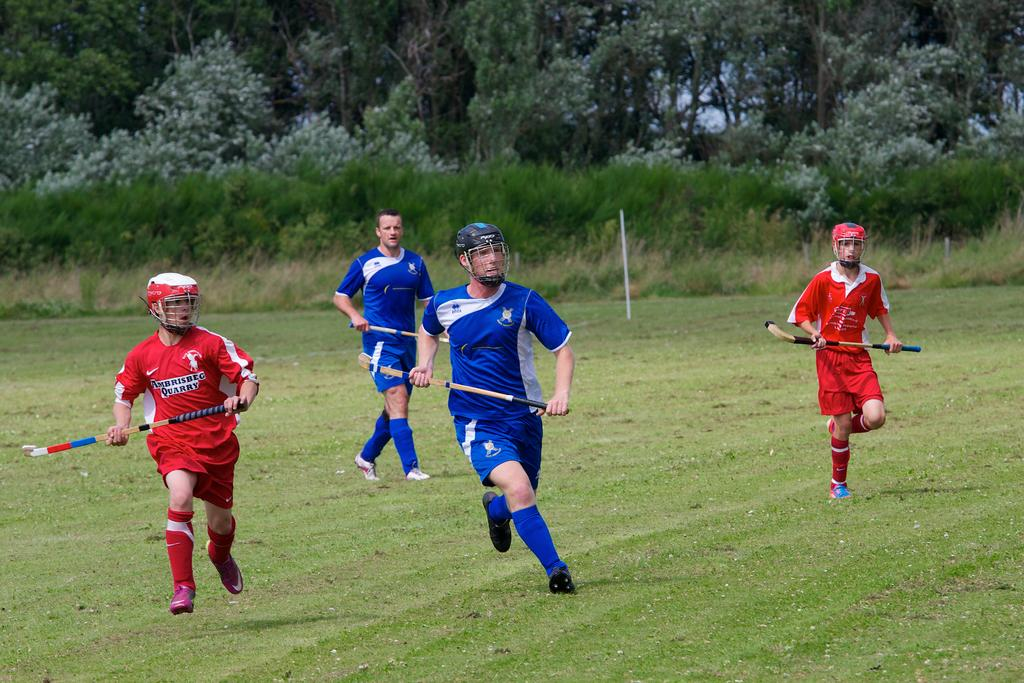<image>
Offer a succinct explanation of the picture presented. Athletes holding a stick with one that says "Ambrisbeg AQUARRY" on their shirt. 